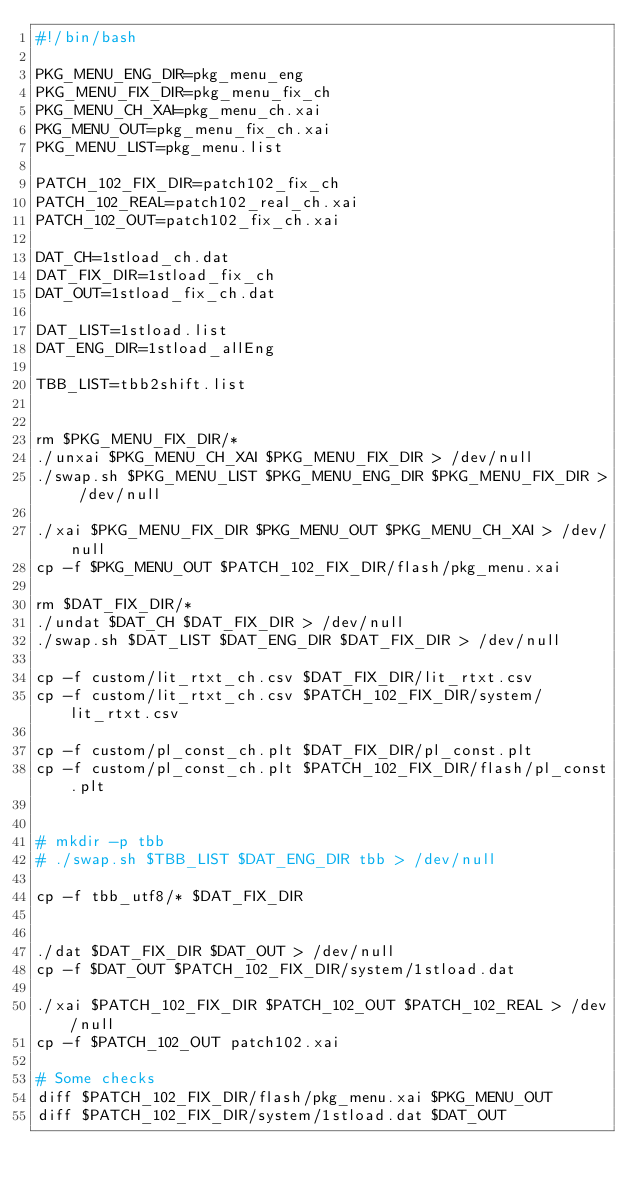<code> <loc_0><loc_0><loc_500><loc_500><_Bash_>#!/bin/bash

PKG_MENU_ENG_DIR=pkg_menu_eng
PKG_MENU_FIX_DIR=pkg_menu_fix_ch
PKG_MENU_CH_XAI=pkg_menu_ch.xai
PKG_MENU_OUT=pkg_menu_fix_ch.xai
PKG_MENU_LIST=pkg_menu.list

PATCH_102_FIX_DIR=patch102_fix_ch
PATCH_102_REAL=patch102_real_ch.xai
PATCH_102_OUT=patch102_fix_ch.xai

DAT_CH=1stload_ch.dat
DAT_FIX_DIR=1stload_fix_ch
DAT_OUT=1stload_fix_ch.dat

DAT_LIST=1stload.list
DAT_ENG_DIR=1stload_allEng

TBB_LIST=tbb2shift.list


rm $PKG_MENU_FIX_DIR/*
./unxai $PKG_MENU_CH_XAI $PKG_MENU_FIX_DIR > /dev/null
./swap.sh $PKG_MENU_LIST $PKG_MENU_ENG_DIR $PKG_MENU_FIX_DIR > /dev/null

./xai $PKG_MENU_FIX_DIR $PKG_MENU_OUT $PKG_MENU_CH_XAI > /dev/null
cp -f $PKG_MENU_OUT $PATCH_102_FIX_DIR/flash/pkg_menu.xai

rm $DAT_FIX_DIR/*
./undat $DAT_CH $DAT_FIX_DIR > /dev/null
./swap.sh $DAT_LIST $DAT_ENG_DIR $DAT_FIX_DIR > /dev/null

cp -f custom/lit_rtxt_ch.csv $DAT_FIX_DIR/lit_rtxt.csv
cp -f custom/lit_rtxt_ch.csv $PATCH_102_FIX_DIR/system/lit_rtxt.csv

cp -f custom/pl_const_ch.plt $DAT_FIX_DIR/pl_const.plt
cp -f custom/pl_const_ch.plt $PATCH_102_FIX_DIR/flash/pl_const.plt


# mkdir -p tbb
# ./swap.sh $TBB_LIST $DAT_ENG_DIR tbb > /dev/null

cp -f tbb_utf8/* $DAT_FIX_DIR


./dat $DAT_FIX_DIR $DAT_OUT > /dev/null
cp -f $DAT_OUT $PATCH_102_FIX_DIR/system/1stload.dat

./xai $PATCH_102_FIX_DIR $PATCH_102_OUT $PATCH_102_REAL > /dev/null
cp -f $PATCH_102_OUT patch102.xai

# Some checks
diff $PATCH_102_FIX_DIR/flash/pkg_menu.xai $PKG_MENU_OUT
diff $PATCH_102_FIX_DIR/system/1stload.dat $DAT_OUT
</code> 